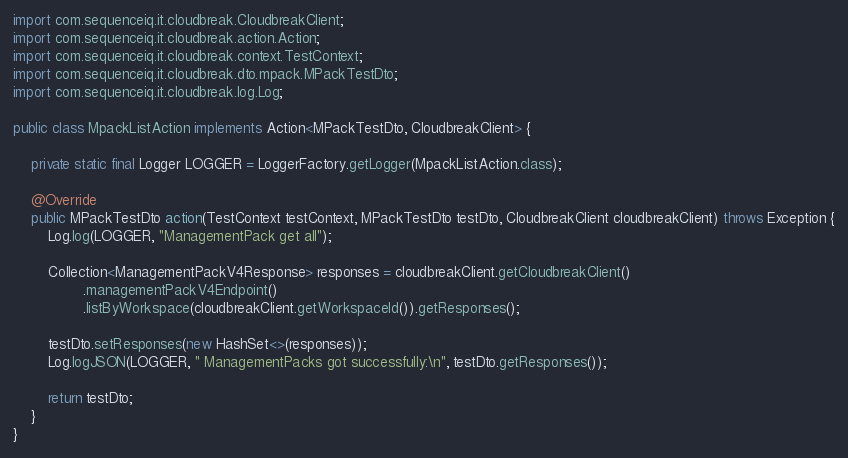<code> <loc_0><loc_0><loc_500><loc_500><_Java_>import com.sequenceiq.it.cloudbreak.CloudbreakClient;
import com.sequenceiq.it.cloudbreak.action.Action;
import com.sequenceiq.it.cloudbreak.context.TestContext;
import com.sequenceiq.it.cloudbreak.dto.mpack.MPackTestDto;
import com.sequenceiq.it.cloudbreak.log.Log;

public class MpackListAction implements Action<MPackTestDto, CloudbreakClient> {

    private static final Logger LOGGER = LoggerFactory.getLogger(MpackListAction.class);

    @Override
    public MPackTestDto action(TestContext testContext, MPackTestDto testDto, CloudbreakClient cloudbreakClient) throws Exception {
        Log.log(LOGGER, "ManagementPack get all");

        Collection<ManagementPackV4Response> responses = cloudbreakClient.getCloudbreakClient()
                .managementPackV4Endpoint()
                .listByWorkspace(cloudbreakClient.getWorkspaceId()).getResponses();

        testDto.setResponses(new HashSet<>(responses));
        Log.logJSON(LOGGER, " ManagementPacks got successfully:\n", testDto.getResponses());

        return testDto;
    }
}
</code> 